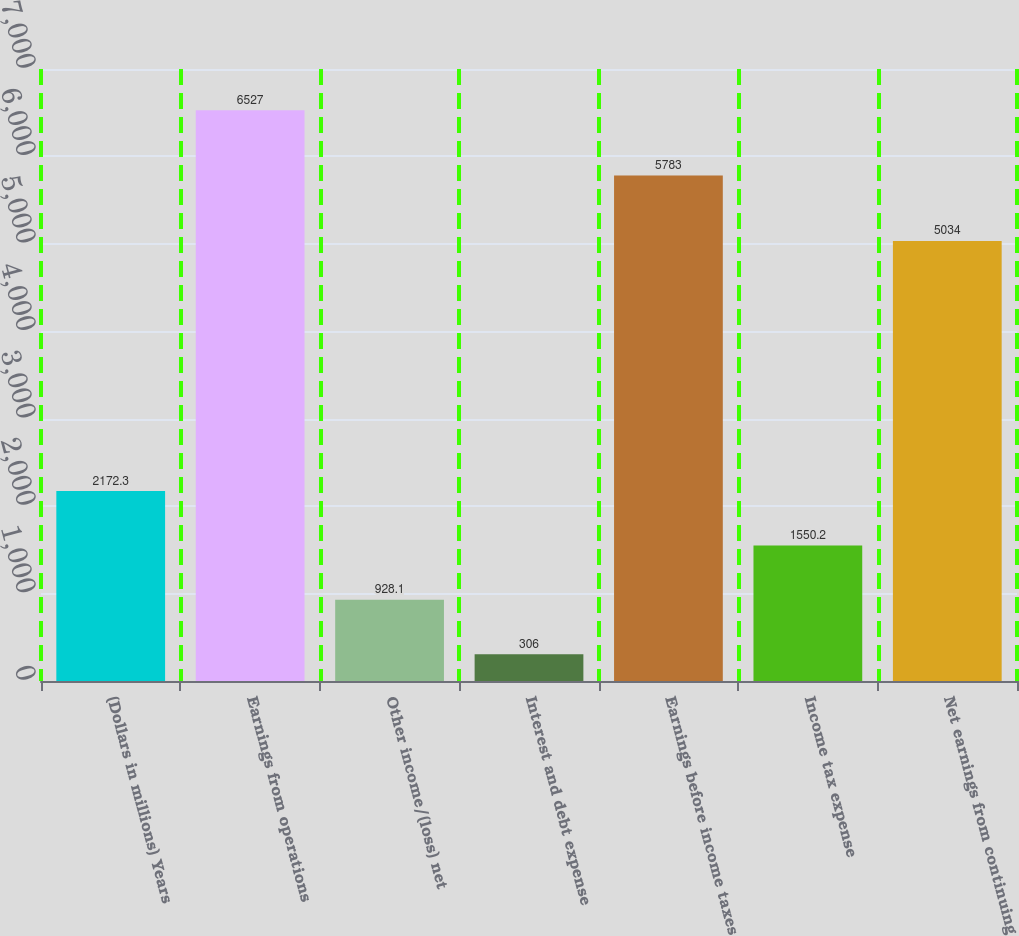Convert chart to OTSL. <chart><loc_0><loc_0><loc_500><loc_500><bar_chart><fcel>(Dollars in millions) Years<fcel>Earnings from operations<fcel>Other income/(loss) net<fcel>Interest and debt expense<fcel>Earnings before income taxes<fcel>Income tax expense<fcel>Net earnings from continuing<nl><fcel>2172.3<fcel>6527<fcel>928.1<fcel>306<fcel>5783<fcel>1550.2<fcel>5034<nl></chart> 